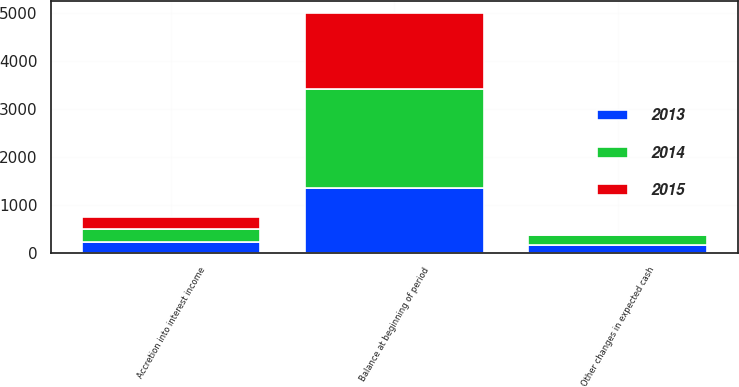Convert chart to OTSL. <chart><loc_0><loc_0><loc_500><loc_500><stacked_bar_chart><ecel><fcel>Balance at beginning of period<fcel>Accretion into interest income<fcel>Other changes in expected cash<nl><fcel>2013<fcel>1341<fcel>220<fcel>156<nl><fcel>2015<fcel>1580<fcel>260<fcel>21<nl><fcel>2014<fcel>2072<fcel>272<fcel>220<nl></chart> 